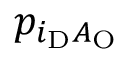<formula> <loc_0><loc_0><loc_500><loc_500>p _ { i _ { D } A _ { O } }</formula> 